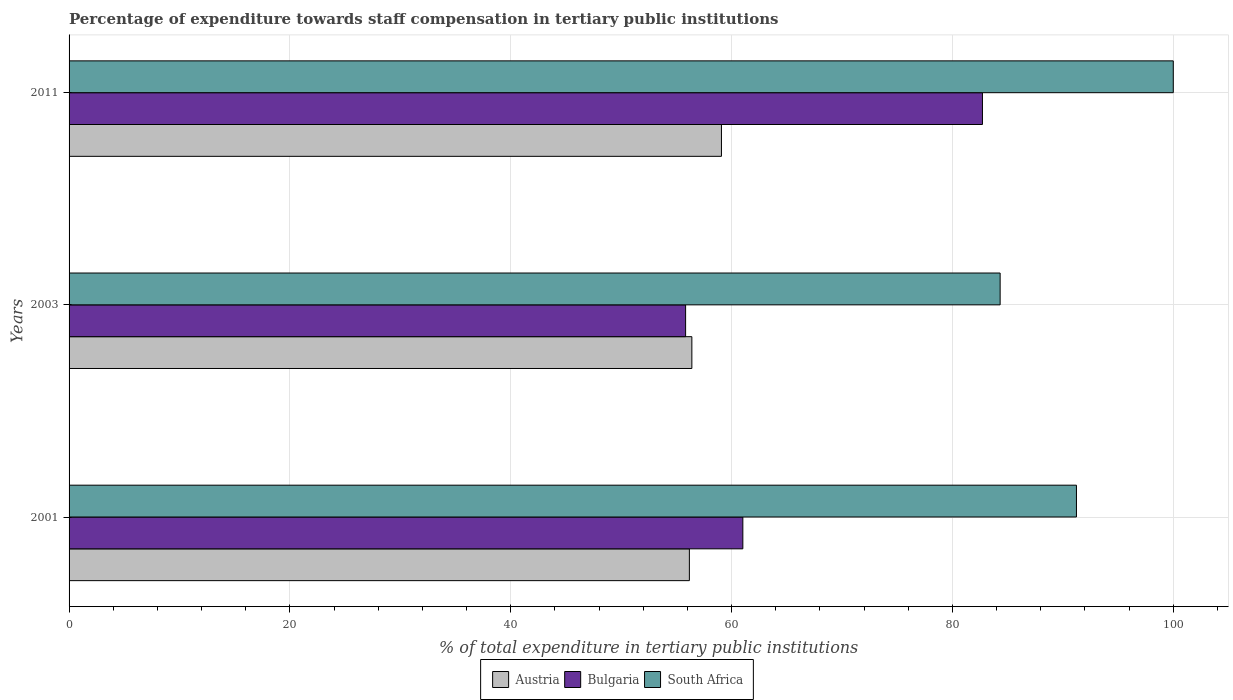How many different coloured bars are there?
Give a very brief answer. 3. How many groups of bars are there?
Offer a very short reply. 3. Are the number of bars on each tick of the Y-axis equal?
Your response must be concise. Yes. How many bars are there on the 2nd tick from the top?
Keep it short and to the point. 3. How many bars are there on the 2nd tick from the bottom?
Offer a very short reply. 3. What is the percentage of expenditure towards staff compensation in Austria in 2011?
Provide a short and direct response. 59.08. Across all years, what is the maximum percentage of expenditure towards staff compensation in South Africa?
Give a very brief answer. 100. Across all years, what is the minimum percentage of expenditure towards staff compensation in Bulgaria?
Offer a terse response. 55.84. In which year was the percentage of expenditure towards staff compensation in Bulgaria maximum?
Ensure brevity in your answer.  2011. What is the total percentage of expenditure towards staff compensation in Austria in the graph?
Offer a terse response. 171.66. What is the difference between the percentage of expenditure towards staff compensation in South Africa in 2003 and that in 2011?
Provide a succinct answer. -15.68. What is the difference between the percentage of expenditure towards staff compensation in Austria in 2001 and the percentage of expenditure towards staff compensation in South Africa in 2003?
Provide a succinct answer. -28.14. What is the average percentage of expenditure towards staff compensation in South Africa per year?
Your answer should be compact. 91.85. In the year 2001, what is the difference between the percentage of expenditure towards staff compensation in South Africa and percentage of expenditure towards staff compensation in Bulgaria?
Keep it short and to the point. 30.21. What is the ratio of the percentage of expenditure towards staff compensation in Austria in 2001 to that in 2003?
Offer a very short reply. 1. What is the difference between the highest and the second highest percentage of expenditure towards staff compensation in South Africa?
Ensure brevity in your answer.  8.77. What is the difference between the highest and the lowest percentage of expenditure towards staff compensation in Austria?
Keep it short and to the point. 2.9. In how many years, is the percentage of expenditure towards staff compensation in Bulgaria greater than the average percentage of expenditure towards staff compensation in Bulgaria taken over all years?
Provide a succinct answer. 1. What does the 1st bar from the top in 2001 represents?
Your answer should be compact. South Africa. How many bars are there?
Offer a very short reply. 9. Are all the bars in the graph horizontal?
Your response must be concise. Yes. How many years are there in the graph?
Offer a terse response. 3. Are the values on the major ticks of X-axis written in scientific E-notation?
Give a very brief answer. No. What is the title of the graph?
Keep it short and to the point. Percentage of expenditure towards staff compensation in tertiary public institutions. Does "Malta" appear as one of the legend labels in the graph?
Give a very brief answer. No. What is the label or title of the X-axis?
Make the answer very short. % of total expenditure in tertiary public institutions. What is the % of total expenditure in tertiary public institutions in Austria in 2001?
Offer a terse response. 56.18. What is the % of total expenditure in tertiary public institutions of Bulgaria in 2001?
Keep it short and to the point. 61.02. What is the % of total expenditure in tertiary public institutions of South Africa in 2001?
Your answer should be compact. 91.23. What is the % of total expenditure in tertiary public institutions of Austria in 2003?
Your response must be concise. 56.4. What is the % of total expenditure in tertiary public institutions in Bulgaria in 2003?
Ensure brevity in your answer.  55.84. What is the % of total expenditure in tertiary public institutions of South Africa in 2003?
Your response must be concise. 84.32. What is the % of total expenditure in tertiary public institutions in Austria in 2011?
Offer a very short reply. 59.08. What is the % of total expenditure in tertiary public institutions of Bulgaria in 2011?
Give a very brief answer. 82.72. What is the % of total expenditure in tertiary public institutions in South Africa in 2011?
Your answer should be very brief. 100. Across all years, what is the maximum % of total expenditure in tertiary public institutions in Austria?
Provide a succinct answer. 59.08. Across all years, what is the maximum % of total expenditure in tertiary public institutions in Bulgaria?
Offer a terse response. 82.72. Across all years, what is the minimum % of total expenditure in tertiary public institutions of Austria?
Provide a short and direct response. 56.18. Across all years, what is the minimum % of total expenditure in tertiary public institutions in Bulgaria?
Your answer should be compact. 55.84. Across all years, what is the minimum % of total expenditure in tertiary public institutions in South Africa?
Make the answer very short. 84.32. What is the total % of total expenditure in tertiary public institutions of Austria in the graph?
Your answer should be compact. 171.66. What is the total % of total expenditure in tertiary public institutions of Bulgaria in the graph?
Ensure brevity in your answer.  199.57. What is the total % of total expenditure in tertiary public institutions of South Africa in the graph?
Ensure brevity in your answer.  275.55. What is the difference between the % of total expenditure in tertiary public institutions of Austria in 2001 and that in 2003?
Ensure brevity in your answer.  -0.22. What is the difference between the % of total expenditure in tertiary public institutions of Bulgaria in 2001 and that in 2003?
Your response must be concise. 5.18. What is the difference between the % of total expenditure in tertiary public institutions of South Africa in 2001 and that in 2003?
Your answer should be compact. 6.91. What is the difference between the % of total expenditure in tertiary public institutions in Austria in 2001 and that in 2011?
Your answer should be compact. -2.9. What is the difference between the % of total expenditure in tertiary public institutions in Bulgaria in 2001 and that in 2011?
Ensure brevity in your answer.  -21.7. What is the difference between the % of total expenditure in tertiary public institutions in South Africa in 2001 and that in 2011?
Keep it short and to the point. -8.77. What is the difference between the % of total expenditure in tertiary public institutions in Austria in 2003 and that in 2011?
Give a very brief answer. -2.68. What is the difference between the % of total expenditure in tertiary public institutions of Bulgaria in 2003 and that in 2011?
Offer a very short reply. -26.88. What is the difference between the % of total expenditure in tertiary public institutions in South Africa in 2003 and that in 2011?
Make the answer very short. -15.68. What is the difference between the % of total expenditure in tertiary public institutions in Austria in 2001 and the % of total expenditure in tertiary public institutions in Bulgaria in 2003?
Offer a terse response. 0.34. What is the difference between the % of total expenditure in tertiary public institutions in Austria in 2001 and the % of total expenditure in tertiary public institutions in South Africa in 2003?
Your response must be concise. -28.14. What is the difference between the % of total expenditure in tertiary public institutions of Bulgaria in 2001 and the % of total expenditure in tertiary public institutions of South Africa in 2003?
Your response must be concise. -23.3. What is the difference between the % of total expenditure in tertiary public institutions in Austria in 2001 and the % of total expenditure in tertiary public institutions in Bulgaria in 2011?
Make the answer very short. -26.54. What is the difference between the % of total expenditure in tertiary public institutions in Austria in 2001 and the % of total expenditure in tertiary public institutions in South Africa in 2011?
Keep it short and to the point. -43.82. What is the difference between the % of total expenditure in tertiary public institutions of Bulgaria in 2001 and the % of total expenditure in tertiary public institutions of South Africa in 2011?
Your answer should be very brief. -38.98. What is the difference between the % of total expenditure in tertiary public institutions of Austria in 2003 and the % of total expenditure in tertiary public institutions of Bulgaria in 2011?
Make the answer very short. -26.32. What is the difference between the % of total expenditure in tertiary public institutions of Austria in 2003 and the % of total expenditure in tertiary public institutions of South Africa in 2011?
Provide a short and direct response. -43.6. What is the difference between the % of total expenditure in tertiary public institutions of Bulgaria in 2003 and the % of total expenditure in tertiary public institutions of South Africa in 2011?
Your response must be concise. -44.16. What is the average % of total expenditure in tertiary public institutions of Austria per year?
Ensure brevity in your answer.  57.22. What is the average % of total expenditure in tertiary public institutions in Bulgaria per year?
Make the answer very short. 66.52. What is the average % of total expenditure in tertiary public institutions in South Africa per year?
Your answer should be very brief. 91.85. In the year 2001, what is the difference between the % of total expenditure in tertiary public institutions of Austria and % of total expenditure in tertiary public institutions of Bulgaria?
Your response must be concise. -4.84. In the year 2001, what is the difference between the % of total expenditure in tertiary public institutions of Austria and % of total expenditure in tertiary public institutions of South Africa?
Your answer should be very brief. -35.05. In the year 2001, what is the difference between the % of total expenditure in tertiary public institutions in Bulgaria and % of total expenditure in tertiary public institutions in South Africa?
Your answer should be very brief. -30.21. In the year 2003, what is the difference between the % of total expenditure in tertiary public institutions of Austria and % of total expenditure in tertiary public institutions of Bulgaria?
Offer a very short reply. 0.57. In the year 2003, what is the difference between the % of total expenditure in tertiary public institutions of Austria and % of total expenditure in tertiary public institutions of South Africa?
Your response must be concise. -27.92. In the year 2003, what is the difference between the % of total expenditure in tertiary public institutions in Bulgaria and % of total expenditure in tertiary public institutions in South Africa?
Your answer should be very brief. -28.48. In the year 2011, what is the difference between the % of total expenditure in tertiary public institutions of Austria and % of total expenditure in tertiary public institutions of Bulgaria?
Your answer should be compact. -23.64. In the year 2011, what is the difference between the % of total expenditure in tertiary public institutions of Austria and % of total expenditure in tertiary public institutions of South Africa?
Provide a short and direct response. -40.92. In the year 2011, what is the difference between the % of total expenditure in tertiary public institutions of Bulgaria and % of total expenditure in tertiary public institutions of South Africa?
Make the answer very short. -17.28. What is the ratio of the % of total expenditure in tertiary public institutions of Bulgaria in 2001 to that in 2003?
Keep it short and to the point. 1.09. What is the ratio of the % of total expenditure in tertiary public institutions in South Africa in 2001 to that in 2003?
Provide a succinct answer. 1.08. What is the ratio of the % of total expenditure in tertiary public institutions in Austria in 2001 to that in 2011?
Offer a terse response. 0.95. What is the ratio of the % of total expenditure in tertiary public institutions of Bulgaria in 2001 to that in 2011?
Your answer should be very brief. 0.74. What is the ratio of the % of total expenditure in tertiary public institutions of South Africa in 2001 to that in 2011?
Offer a terse response. 0.91. What is the ratio of the % of total expenditure in tertiary public institutions in Austria in 2003 to that in 2011?
Your response must be concise. 0.95. What is the ratio of the % of total expenditure in tertiary public institutions in Bulgaria in 2003 to that in 2011?
Keep it short and to the point. 0.68. What is the ratio of the % of total expenditure in tertiary public institutions of South Africa in 2003 to that in 2011?
Your answer should be compact. 0.84. What is the difference between the highest and the second highest % of total expenditure in tertiary public institutions in Austria?
Your response must be concise. 2.68. What is the difference between the highest and the second highest % of total expenditure in tertiary public institutions in Bulgaria?
Your answer should be compact. 21.7. What is the difference between the highest and the second highest % of total expenditure in tertiary public institutions in South Africa?
Your response must be concise. 8.77. What is the difference between the highest and the lowest % of total expenditure in tertiary public institutions of Austria?
Provide a short and direct response. 2.9. What is the difference between the highest and the lowest % of total expenditure in tertiary public institutions in Bulgaria?
Provide a short and direct response. 26.88. What is the difference between the highest and the lowest % of total expenditure in tertiary public institutions of South Africa?
Your answer should be compact. 15.68. 